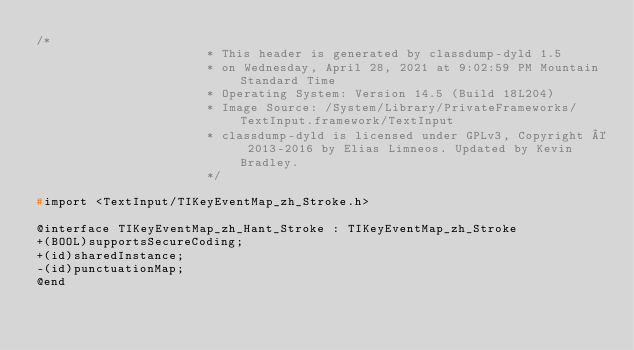<code> <loc_0><loc_0><loc_500><loc_500><_C_>/*
                       * This header is generated by classdump-dyld 1.5
                       * on Wednesday, April 28, 2021 at 9:02:59 PM Mountain Standard Time
                       * Operating System: Version 14.5 (Build 18L204)
                       * Image Source: /System/Library/PrivateFrameworks/TextInput.framework/TextInput
                       * classdump-dyld is licensed under GPLv3, Copyright © 2013-2016 by Elias Limneos. Updated by Kevin Bradley.
                       */

#import <TextInput/TIKeyEventMap_zh_Stroke.h>

@interface TIKeyEventMap_zh_Hant_Stroke : TIKeyEventMap_zh_Stroke
+(BOOL)supportsSecureCoding;
+(id)sharedInstance;
-(id)punctuationMap;
@end

</code> 